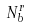Convert formula to latex. <formula><loc_0><loc_0><loc_500><loc_500>N _ { b } ^ { r }</formula> 